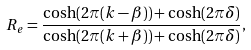Convert formula to latex. <formula><loc_0><loc_0><loc_500><loc_500>R _ { e } = \frac { \cosh ( 2 \pi ( k - \beta ) ) + \cosh ( 2 \pi \delta ) } { \cosh ( 2 \pi ( k + \beta ) ) + \cosh ( 2 \pi \delta ) } ,</formula> 